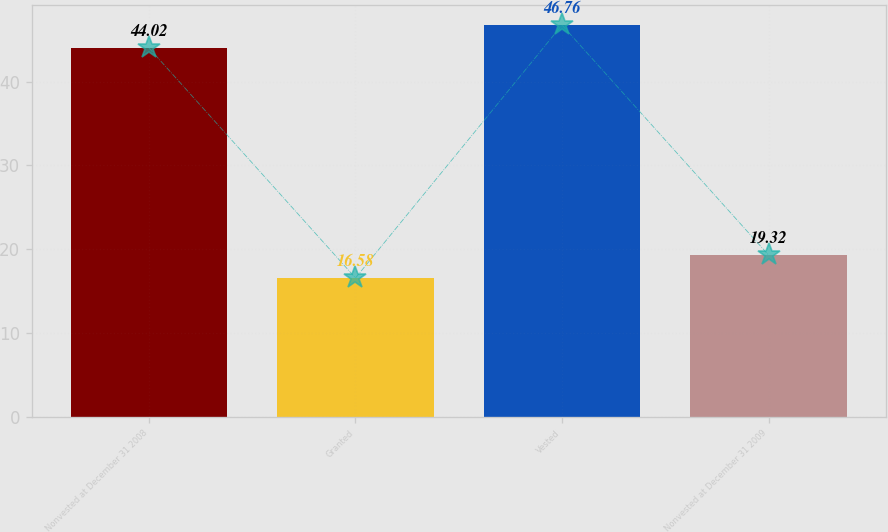Convert chart to OTSL. <chart><loc_0><loc_0><loc_500><loc_500><bar_chart><fcel>Nonvested at December 31 2008<fcel>Granted<fcel>Vested<fcel>Nonvested at December 31 2009<nl><fcel>44.02<fcel>16.58<fcel>46.76<fcel>19.32<nl></chart> 